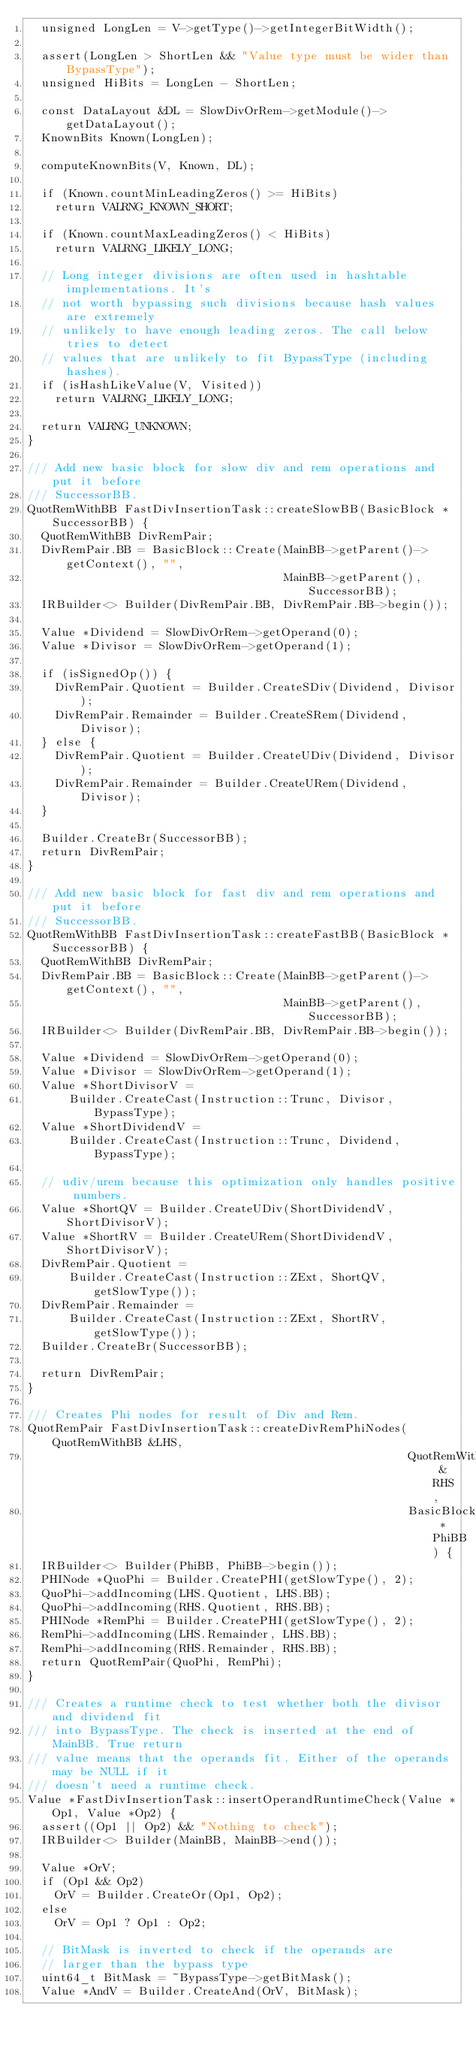<code> <loc_0><loc_0><loc_500><loc_500><_C++_>  unsigned LongLen = V->getType()->getIntegerBitWidth();

  assert(LongLen > ShortLen && "Value type must be wider than BypassType");
  unsigned HiBits = LongLen - ShortLen;

  const DataLayout &DL = SlowDivOrRem->getModule()->getDataLayout();
  KnownBits Known(LongLen);

  computeKnownBits(V, Known, DL);

  if (Known.countMinLeadingZeros() >= HiBits)
    return VALRNG_KNOWN_SHORT;

  if (Known.countMaxLeadingZeros() < HiBits)
    return VALRNG_LIKELY_LONG;

  // Long integer divisions are often used in hashtable implementations. It's
  // not worth bypassing such divisions because hash values are extremely
  // unlikely to have enough leading zeros. The call below tries to detect
  // values that are unlikely to fit BypassType (including hashes).
  if (isHashLikeValue(V, Visited))
    return VALRNG_LIKELY_LONG;

  return VALRNG_UNKNOWN;
}

/// Add new basic block for slow div and rem operations and put it before
/// SuccessorBB.
QuotRemWithBB FastDivInsertionTask::createSlowBB(BasicBlock *SuccessorBB) {
  QuotRemWithBB DivRemPair;
  DivRemPair.BB = BasicBlock::Create(MainBB->getParent()->getContext(), "",
                                     MainBB->getParent(), SuccessorBB);
  IRBuilder<> Builder(DivRemPair.BB, DivRemPair.BB->begin());

  Value *Dividend = SlowDivOrRem->getOperand(0);
  Value *Divisor = SlowDivOrRem->getOperand(1);

  if (isSignedOp()) {
    DivRemPair.Quotient = Builder.CreateSDiv(Dividend, Divisor);
    DivRemPair.Remainder = Builder.CreateSRem(Dividend, Divisor);
  } else {
    DivRemPair.Quotient = Builder.CreateUDiv(Dividend, Divisor);
    DivRemPair.Remainder = Builder.CreateURem(Dividend, Divisor);
  }

  Builder.CreateBr(SuccessorBB);
  return DivRemPair;
}

/// Add new basic block for fast div and rem operations and put it before
/// SuccessorBB.
QuotRemWithBB FastDivInsertionTask::createFastBB(BasicBlock *SuccessorBB) {
  QuotRemWithBB DivRemPair;
  DivRemPair.BB = BasicBlock::Create(MainBB->getParent()->getContext(), "",
                                     MainBB->getParent(), SuccessorBB);
  IRBuilder<> Builder(DivRemPair.BB, DivRemPair.BB->begin());

  Value *Dividend = SlowDivOrRem->getOperand(0);
  Value *Divisor = SlowDivOrRem->getOperand(1);
  Value *ShortDivisorV =
      Builder.CreateCast(Instruction::Trunc, Divisor, BypassType);
  Value *ShortDividendV =
      Builder.CreateCast(Instruction::Trunc, Dividend, BypassType);

  // udiv/urem because this optimization only handles positive numbers.
  Value *ShortQV = Builder.CreateUDiv(ShortDividendV, ShortDivisorV);
  Value *ShortRV = Builder.CreateURem(ShortDividendV, ShortDivisorV);
  DivRemPair.Quotient =
      Builder.CreateCast(Instruction::ZExt, ShortQV, getSlowType());
  DivRemPair.Remainder =
      Builder.CreateCast(Instruction::ZExt, ShortRV, getSlowType());
  Builder.CreateBr(SuccessorBB);

  return DivRemPair;
}

/// Creates Phi nodes for result of Div and Rem.
QuotRemPair FastDivInsertionTask::createDivRemPhiNodes(QuotRemWithBB &LHS,
                                                       QuotRemWithBB &RHS,
                                                       BasicBlock *PhiBB) {
  IRBuilder<> Builder(PhiBB, PhiBB->begin());
  PHINode *QuoPhi = Builder.CreatePHI(getSlowType(), 2);
  QuoPhi->addIncoming(LHS.Quotient, LHS.BB);
  QuoPhi->addIncoming(RHS.Quotient, RHS.BB);
  PHINode *RemPhi = Builder.CreatePHI(getSlowType(), 2);
  RemPhi->addIncoming(LHS.Remainder, LHS.BB);
  RemPhi->addIncoming(RHS.Remainder, RHS.BB);
  return QuotRemPair(QuoPhi, RemPhi);
}

/// Creates a runtime check to test whether both the divisor and dividend fit
/// into BypassType. The check is inserted at the end of MainBB. True return
/// value means that the operands fit. Either of the operands may be NULL if it
/// doesn't need a runtime check.
Value *FastDivInsertionTask::insertOperandRuntimeCheck(Value *Op1, Value *Op2) {
  assert((Op1 || Op2) && "Nothing to check");
  IRBuilder<> Builder(MainBB, MainBB->end());

  Value *OrV;
  if (Op1 && Op2)
    OrV = Builder.CreateOr(Op1, Op2);
  else
    OrV = Op1 ? Op1 : Op2;

  // BitMask is inverted to check if the operands are
  // larger than the bypass type
  uint64_t BitMask = ~BypassType->getBitMask();
  Value *AndV = Builder.CreateAnd(OrV, BitMask);
</code> 